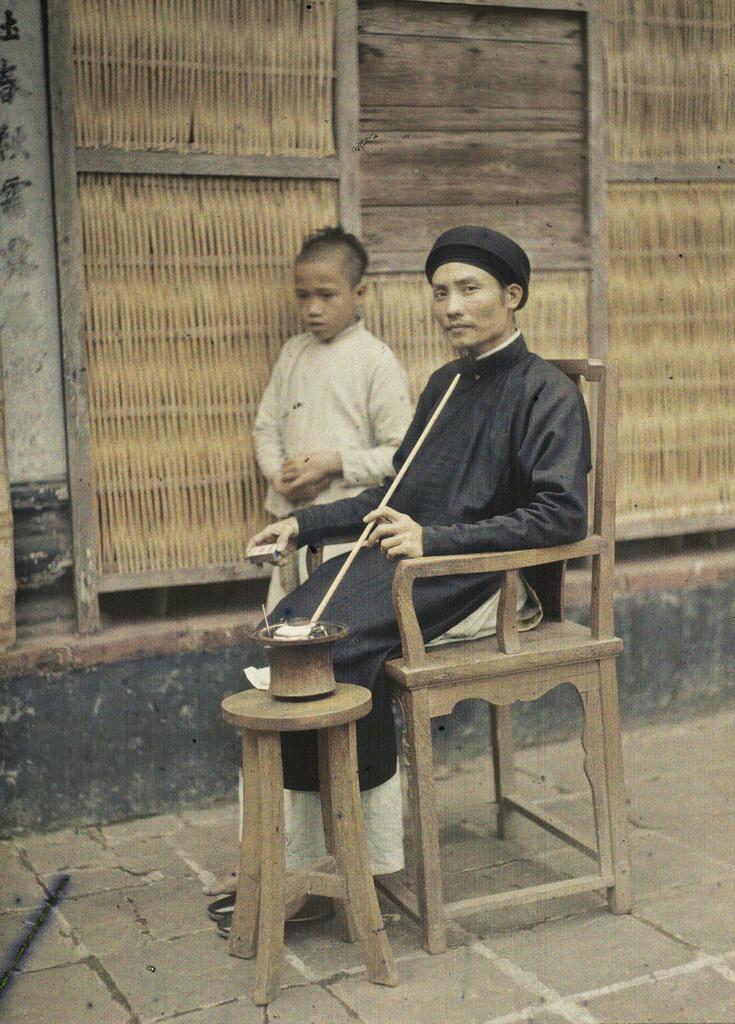Describe this image in one or two sentences. There is a man sitting on wooden chair and a boy boy standing beside him, there is a table placed beside him and a bowl in it with something in. 